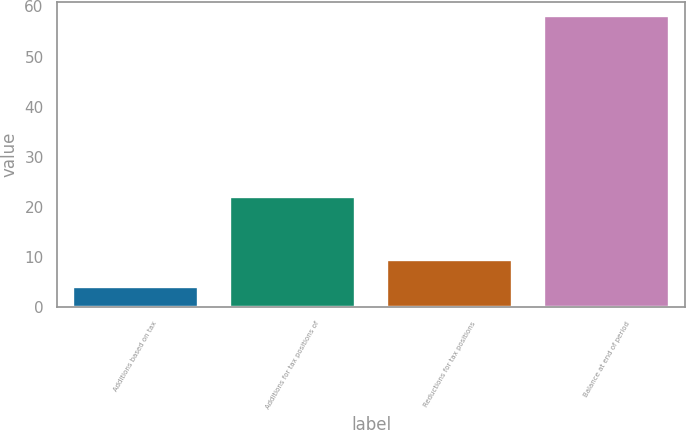<chart> <loc_0><loc_0><loc_500><loc_500><bar_chart><fcel>Additions based on tax<fcel>Additions for tax positions of<fcel>Reductions for tax positions<fcel>Balance at end of period<nl><fcel>4<fcel>22<fcel>9.4<fcel>58<nl></chart> 